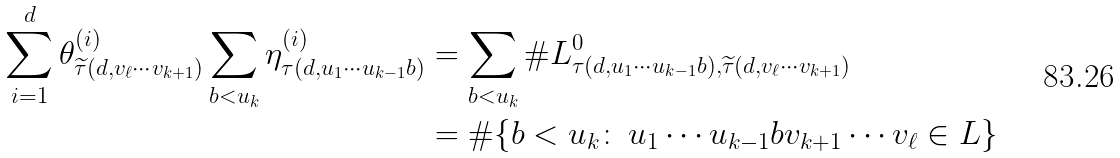<formula> <loc_0><loc_0><loc_500><loc_500>\sum _ { i = 1 } ^ { d } \theta _ { \widetilde { \tau } ( d , v _ { \ell } \cdots v _ { k + 1 } ) } ^ { ( i ) } \sum _ { b < u _ { k } } \eta _ { \tau ( d , u _ { 1 } \cdots u _ { k - 1 } b ) } ^ { ( i ) } & = \sum _ { b < u _ { k } } \# L _ { \tau ( d , u _ { 1 } \cdots u _ { k - 1 } b ) , \widetilde { \tau } ( d , v _ { \ell } \cdots v _ { k + 1 } ) } ^ { 0 } \\ & = \# \{ b < u _ { k } \colon \, u _ { 1 } \cdots u _ { k - 1 } b v _ { k + 1 } \cdots v _ { \ell } \in L \}</formula> 